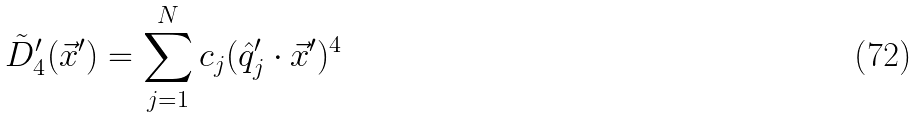<formula> <loc_0><loc_0><loc_500><loc_500>\tilde { D } ^ { \prime } _ { 4 } ( \vec { x } ^ { \prime } ) = \sum _ { j = 1 } ^ { N } c _ { j } ( \hat { q } ^ { \prime } _ { j } \cdot \vec { x } ^ { \prime } ) ^ { 4 }</formula> 